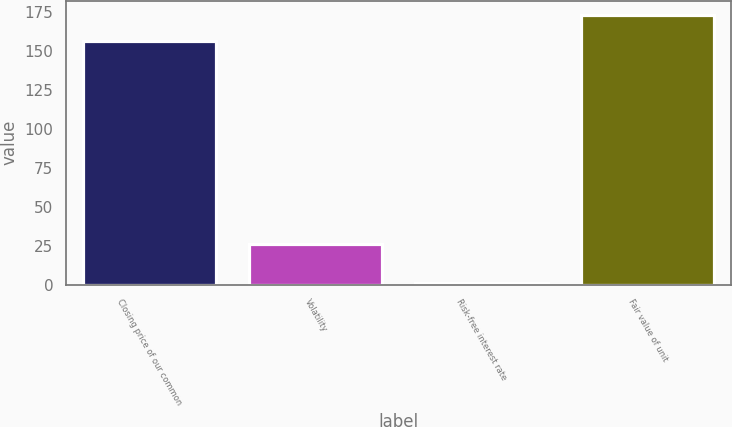Convert chart to OTSL. <chart><loc_0><loc_0><loc_500><loc_500><bar_chart><fcel>Closing price of our common<fcel>Volatility<fcel>Risk-free interest rate<fcel>Fair value of unit<nl><fcel>156.35<fcel>25.8<fcel>0.9<fcel>173.32<nl></chart> 